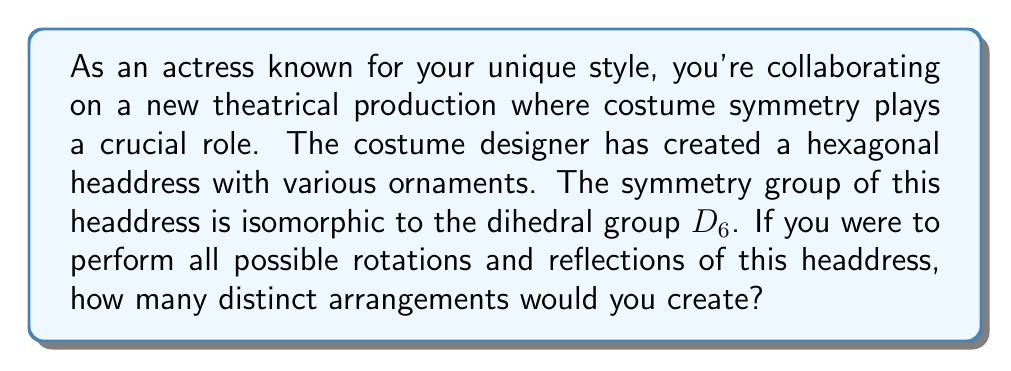Provide a solution to this math problem. To solve this problem, we need to understand the properties of the dihedral group $D_6$ and how it relates to the symmetries of a hexagon:

1. The dihedral group $D_6$ represents the symmetries of a regular hexagon.

2. The order of $D_6$ is given by the formula $|D_n| = 2n$, where $n$ is the number of sides of the polygon. In this case:

   $|D_6| = 2 \cdot 6 = 12$

3. The 12 elements of $D_6$ consist of:
   - 6 rotations (including the identity rotation)
   - 6 reflections

4. Each of these symmetry operations, when applied to the headdress, will create a distinct arrangement.

5. The number of distinct arrangements is equal to the order of the group, as each group element corresponds to a unique transformation of the headdress.

Therefore, the number of distinct arrangements is equal to the order of $D_6$, which is 12.

[asy]
unitsize(30);
for(int i=0; i<6; ++i) {
  draw(rotate(60*i)*(1,0)--(cos(pi/3),sin(pi/3)), arrow=Arrow(TeXHead));
}
for(int i=0; i<6; ++i) {
  draw(rotate(30+60*i)*(1,0)--(-1,0), dashed);
}
[/asy]

The diagram above illustrates the symmetries of a hexagon, showing the 6 rotational symmetries (arrows) and 6 reflection symmetries (dashed lines).
Answer: 12 distinct arrangements 